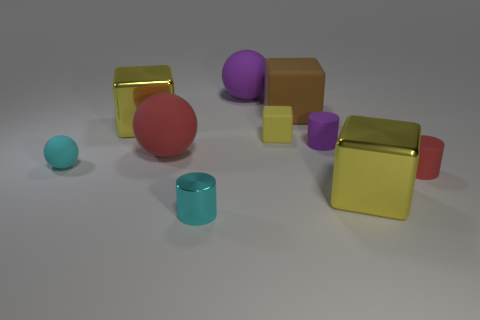How does the lighting in the scene affect the appearance of the objects? The lighting in the scene casts soft shadows and highlights the shapes and textures of the objects, enhancing the three-dimensional look and adding depth to the overall composition. 